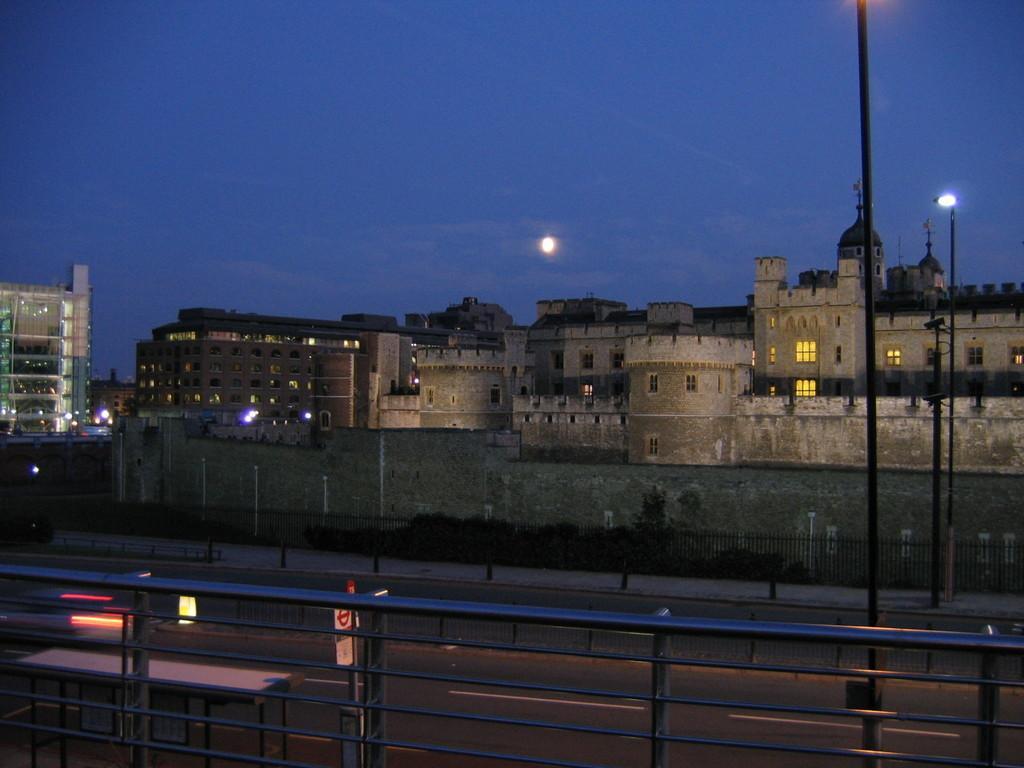Please provide a concise description of this image. In this image we can see so many buildings, so many lights, two street lights, one table, so many poles, one big wall, one sign board attached to the pole, one road, two fences and so many there. Some objects on the surface and at the top there is a moon in the sky. 